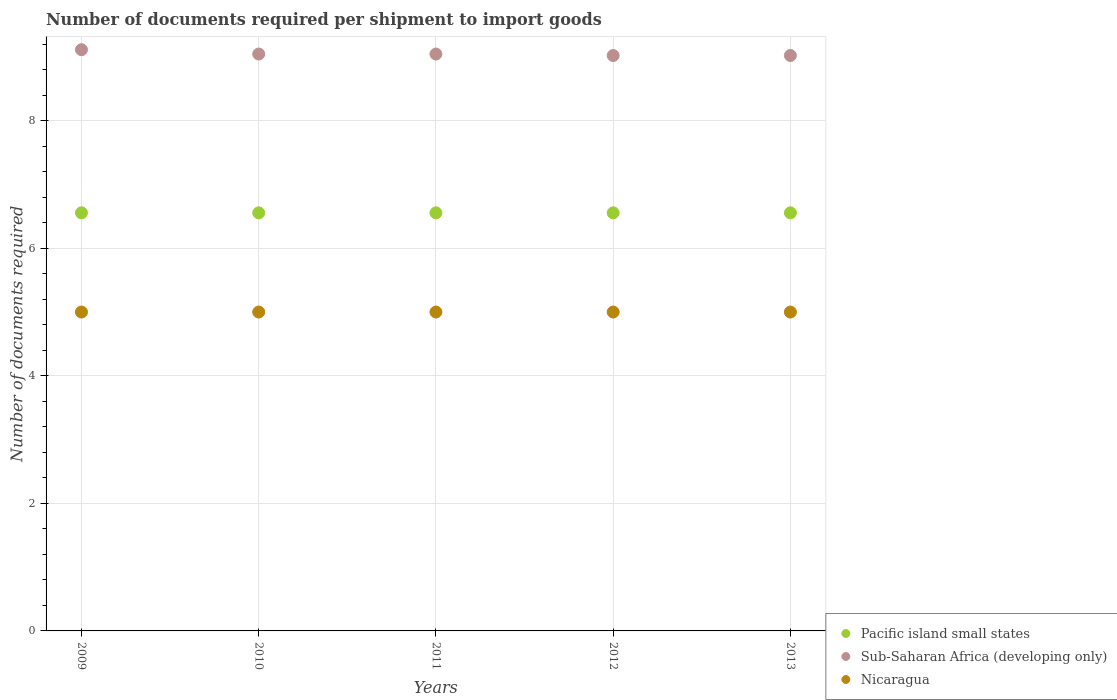What is the number of documents required per shipment to import goods in Sub-Saharan Africa (developing only) in 2013?
Offer a terse response. 9.02. Across all years, what is the maximum number of documents required per shipment to import goods in Nicaragua?
Keep it short and to the point. 5. Across all years, what is the minimum number of documents required per shipment to import goods in Sub-Saharan Africa (developing only)?
Offer a very short reply. 9.02. In which year was the number of documents required per shipment to import goods in Nicaragua minimum?
Your answer should be very brief. 2009. What is the total number of documents required per shipment to import goods in Pacific island small states in the graph?
Offer a very short reply. 32.78. What is the difference between the number of documents required per shipment to import goods in Pacific island small states in 2011 and the number of documents required per shipment to import goods in Nicaragua in 2012?
Provide a short and direct response. 1.56. What is the average number of documents required per shipment to import goods in Nicaragua per year?
Offer a terse response. 5. In the year 2013, what is the difference between the number of documents required per shipment to import goods in Sub-Saharan Africa (developing only) and number of documents required per shipment to import goods in Nicaragua?
Keep it short and to the point. 4.02. What is the ratio of the number of documents required per shipment to import goods in Nicaragua in 2009 to that in 2010?
Make the answer very short. 1. Is the number of documents required per shipment to import goods in Sub-Saharan Africa (developing only) in 2009 less than that in 2012?
Your answer should be very brief. No. What is the difference between the highest and the second highest number of documents required per shipment to import goods in Sub-Saharan Africa (developing only)?
Your answer should be compact. 0.07. In how many years, is the number of documents required per shipment to import goods in Pacific island small states greater than the average number of documents required per shipment to import goods in Pacific island small states taken over all years?
Your answer should be very brief. 0. What is the difference between two consecutive major ticks on the Y-axis?
Give a very brief answer. 2. Does the graph contain grids?
Provide a succinct answer. Yes. Where does the legend appear in the graph?
Provide a short and direct response. Bottom right. How many legend labels are there?
Make the answer very short. 3. How are the legend labels stacked?
Offer a terse response. Vertical. What is the title of the graph?
Offer a very short reply. Number of documents required per shipment to import goods. What is the label or title of the X-axis?
Your answer should be very brief. Years. What is the label or title of the Y-axis?
Give a very brief answer. Number of documents required. What is the Number of documents required of Pacific island small states in 2009?
Offer a terse response. 6.56. What is the Number of documents required of Sub-Saharan Africa (developing only) in 2009?
Keep it short and to the point. 9.11. What is the Number of documents required of Pacific island small states in 2010?
Provide a succinct answer. 6.56. What is the Number of documents required in Sub-Saharan Africa (developing only) in 2010?
Ensure brevity in your answer.  9.05. What is the Number of documents required of Nicaragua in 2010?
Make the answer very short. 5. What is the Number of documents required in Pacific island small states in 2011?
Ensure brevity in your answer.  6.56. What is the Number of documents required of Sub-Saharan Africa (developing only) in 2011?
Make the answer very short. 9.05. What is the Number of documents required in Nicaragua in 2011?
Your answer should be compact. 5. What is the Number of documents required in Pacific island small states in 2012?
Keep it short and to the point. 6.56. What is the Number of documents required of Sub-Saharan Africa (developing only) in 2012?
Give a very brief answer. 9.02. What is the Number of documents required of Pacific island small states in 2013?
Keep it short and to the point. 6.56. What is the Number of documents required of Sub-Saharan Africa (developing only) in 2013?
Give a very brief answer. 9.02. What is the Number of documents required of Nicaragua in 2013?
Your answer should be compact. 5. Across all years, what is the maximum Number of documents required of Pacific island small states?
Offer a very short reply. 6.56. Across all years, what is the maximum Number of documents required of Sub-Saharan Africa (developing only)?
Keep it short and to the point. 9.11. Across all years, what is the maximum Number of documents required in Nicaragua?
Your response must be concise. 5. Across all years, what is the minimum Number of documents required of Pacific island small states?
Make the answer very short. 6.56. Across all years, what is the minimum Number of documents required in Sub-Saharan Africa (developing only)?
Offer a very short reply. 9.02. What is the total Number of documents required in Pacific island small states in the graph?
Offer a terse response. 32.78. What is the total Number of documents required in Sub-Saharan Africa (developing only) in the graph?
Your answer should be compact. 45.25. What is the difference between the Number of documents required of Sub-Saharan Africa (developing only) in 2009 and that in 2010?
Keep it short and to the point. 0.07. What is the difference between the Number of documents required of Nicaragua in 2009 and that in 2010?
Your answer should be compact. 0. What is the difference between the Number of documents required of Sub-Saharan Africa (developing only) in 2009 and that in 2011?
Your answer should be compact. 0.07. What is the difference between the Number of documents required in Pacific island small states in 2009 and that in 2012?
Provide a succinct answer. 0. What is the difference between the Number of documents required of Sub-Saharan Africa (developing only) in 2009 and that in 2012?
Offer a very short reply. 0.09. What is the difference between the Number of documents required of Sub-Saharan Africa (developing only) in 2009 and that in 2013?
Your answer should be very brief. 0.09. What is the difference between the Number of documents required in Nicaragua in 2009 and that in 2013?
Your answer should be compact. 0. What is the difference between the Number of documents required in Pacific island small states in 2010 and that in 2011?
Make the answer very short. 0. What is the difference between the Number of documents required in Sub-Saharan Africa (developing only) in 2010 and that in 2011?
Make the answer very short. 0. What is the difference between the Number of documents required in Pacific island small states in 2010 and that in 2012?
Keep it short and to the point. 0. What is the difference between the Number of documents required in Sub-Saharan Africa (developing only) in 2010 and that in 2012?
Your response must be concise. 0.02. What is the difference between the Number of documents required of Nicaragua in 2010 and that in 2012?
Ensure brevity in your answer.  0. What is the difference between the Number of documents required of Sub-Saharan Africa (developing only) in 2010 and that in 2013?
Ensure brevity in your answer.  0.02. What is the difference between the Number of documents required in Sub-Saharan Africa (developing only) in 2011 and that in 2012?
Offer a terse response. 0.02. What is the difference between the Number of documents required in Pacific island small states in 2011 and that in 2013?
Offer a terse response. 0. What is the difference between the Number of documents required of Sub-Saharan Africa (developing only) in 2011 and that in 2013?
Make the answer very short. 0.02. What is the difference between the Number of documents required in Pacific island small states in 2009 and the Number of documents required in Sub-Saharan Africa (developing only) in 2010?
Your answer should be compact. -2.49. What is the difference between the Number of documents required of Pacific island small states in 2009 and the Number of documents required of Nicaragua in 2010?
Give a very brief answer. 1.56. What is the difference between the Number of documents required of Sub-Saharan Africa (developing only) in 2009 and the Number of documents required of Nicaragua in 2010?
Provide a succinct answer. 4.11. What is the difference between the Number of documents required of Pacific island small states in 2009 and the Number of documents required of Sub-Saharan Africa (developing only) in 2011?
Ensure brevity in your answer.  -2.49. What is the difference between the Number of documents required in Pacific island small states in 2009 and the Number of documents required in Nicaragua in 2011?
Provide a succinct answer. 1.56. What is the difference between the Number of documents required in Sub-Saharan Africa (developing only) in 2009 and the Number of documents required in Nicaragua in 2011?
Offer a very short reply. 4.11. What is the difference between the Number of documents required in Pacific island small states in 2009 and the Number of documents required in Sub-Saharan Africa (developing only) in 2012?
Make the answer very short. -2.47. What is the difference between the Number of documents required in Pacific island small states in 2009 and the Number of documents required in Nicaragua in 2012?
Provide a succinct answer. 1.56. What is the difference between the Number of documents required of Sub-Saharan Africa (developing only) in 2009 and the Number of documents required of Nicaragua in 2012?
Ensure brevity in your answer.  4.11. What is the difference between the Number of documents required in Pacific island small states in 2009 and the Number of documents required in Sub-Saharan Africa (developing only) in 2013?
Give a very brief answer. -2.47. What is the difference between the Number of documents required in Pacific island small states in 2009 and the Number of documents required in Nicaragua in 2013?
Your answer should be compact. 1.56. What is the difference between the Number of documents required in Sub-Saharan Africa (developing only) in 2009 and the Number of documents required in Nicaragua in 2013?
Give a very brief answer. 4.11. What is the difference between the Number of documents required of Pacific island small states in 2010 and the Number of documents required of Sub-Saharan Africa (developing only) in 2011?
Offer a terse response. -2.49. What is the difference between the Number of documents required of Pacific island small states in 2010 and the Number of documents required of Nicaragua in 2011?
Ensure brevity in your answer.  1.56. What is the difference between the Number of documents required in Sub-Saharan Africa (developing only) in 2010 and the Number of documents required in Nicaragua in 2011?
Provide a short and direct response. 4.05. What is the difference between the Number of documents required in Pacific island small states in 2010 and the Number of documents required in Sub-Saharan Africa (developing only) in 2012?
Make the answer very short. -2.47. What is the difference between the Number of documents required of Pacific island small states in 2010 and the Number of documents required of Nicaragua in 2012?
Your answer should be very brief. 1.56. What is the difference between the Number of documents required of Sub-Saharan Africa (developing only) in 2010 and the Number of documents required of Nicaragua in 2012?
Make the answer very short. 4.05. What is the difference between the Number of documents required in Pacific island small states in 2010 and the Number of documents required in Sub-Saharan Africa (developing only) in 2013?
Your answer should be very brief. -2.47. What is the difference between the Number of documents required in Pacific island small states in 2010 and the Number of documents required in Nicaragua in 2013?
Your answer should be compact. 1.56. What is the difference between the Number of documents required of Sub-Saharan Africa (developing only) in 2010 and the Number of documents required of Nicaragua in 2013?
Your answer should be very brief. 4.05. What is the difference between the Number of documents required of Pacific island small states in 2011 and the Number of documents required of Sub-Saharan Africa (developing only) in 2012?
Ensure brevity in your answer.  -2.47. What is the difference between the Number of documents required in Pacific island small states in 2011 and the Number of documents required in Nicaragua in 2012?
Give a very brief answer. 1.56. What is the difference between the Number of documents required in Sub-Saharan Africa (developing only) in 2011 and the Number of documents required in Nicaragua in 2012?
Provide a short and direct response. 4.05. What is the difference between the Number of documents required of Pacific island small states in 2011 and the Number of documents required of Sub-Saharan Africa (developing only) in 2013?
Your response must be concise. -2.47. What is the difference between the Number of documents required of Pacific island small states in 2011 and the Number of documents required of Nicaragua in 2013?
Your answer should be compact. 1.56. What is the difference between the Number of documents required of Sub-Saharan Africa (developing only) in 2011 and the Number of documents required of Nicaragua in 2013?
Ensure brevity in your answer.  4.05. What is the difference between the Number of documents required in Pacific island small states in 2012 and the Number of documents required in Sub-Saharan Africa (developing only) in 2013?
Your answer should be compact. -2.47. What is the difference between the Number of documents required of Pacific island small states in 2012 and the Number of documents required of Nicaragua in 2013?
Keep it short and to the point. 1.56. What is the difference between the Number of documents required in Sub-Saharan Africa (developing only) in 2012 and the Number of documents required in Nicaragua in 2013?
Keep it short and to the point. 4.02. What is the average Number of documents required in Pacific island small states per year?
Give a very brief answer. 6.56. What is the average Number of documents required in Sub-Saharan Africa (developing only) per year?
Keep it short and to the point. 9.05. What is the average Number of documents required of Nicaragua per year?
Provide a succinct answer. 5. In the year 2009, what is the difference between the Number of documents required in Pacific island small states and Number of documents required in Sub-Saharan Africa (developing only)?
Make the answer very short. -2.56. In the year 2009, what is the difference between the Number of documents required in Pacific island small states and Number of documents required in Nicaragua?
Provide a short and direct response. 1.56. In the year 2009, what is the difference between the Number of documents required in Sub-Saharan Africa (developing only) and Number of documents required in Nicaragua?
Keep it short and to the point. 4.11. In the year 2010, what is the difference between the Number of documents required of Pacific island small states and Number of documents required of Sub-Saharan Africa (developing only)?
Make the answer very short. -2.49. In the year 2010, what is the difference between the Number of documents required in Pacific island small states and Number of documents required in Nicaragua?
Give a very brief answer. 1.56. In the year 2010, what is the difference between the Number of documents required of Sub-Saharan Africa (developing only) and Number of documents required of Nicaragua?
Give a very brief answer. 4.05. In the year 2011, what is the difference between the Number of documents required of Pacific island small states and Number of documents required of Sub-Saharan Africa (developing only)?
Your answer should be very brief. -2.49. In the year 2011, what is the difference between the Number of documents required of Pacific island small states and Number of documents required of Nicaragua?
Provide a short and direct response. 1.56. In the year 2011, what is the difference between the Number of documents required of Sub-Saharan Africa (developing only) and Number of documents required of Nicaragua?
Keep it short and to the point. 4.05. In the year 2012, what is the difference between the Number of documents required in Pacific island small states and Number of documents required in Sub-Saharan Africa (developing only)?
Your answer should be very brief. -2.47. In the year 2012, what is the difference between the Number of documents required in Pacific island small states and Number of documents required in Nicaragua?
Provide a succinct answer. 1.56. In the year 2012, what is the difference between the Number of documents required of Sub-Saharan Africa (developing only) and Number of documents required of Nicaragua?
Give a very brief answer. 4.02. In the year 2013, what is the difference between the Number of documents required in Pacific island small states and Number of documents required in Sub-Saharan Africa (developing only)?
Give a very brief answer. -2.47. In the year 2013, what is the difference between the Number of documents required of Pacific island small states and Number of documents required of Nicaragua?
Ensure brevity in your answer.  1.56. In the year 2013, what is the difference between the Number of documents required in Sub-Saharan Africa (developing only) and Number of documents required in Nicaragua?
Keep it short and to the point. 4.02. What is the ratio of the Number of documents required of Pacific island small states in 2009 to that in 2010?
Your response must be concise. 1. What is the ratio of the Number of documents required in Sub-Saharan Africa (developing only) in 2009 to that in 2010?
Your response must be concise. 1.01. What is the ratio of the Number of documents required of Nicaragua in 2009 to that in 2010?
Your response must be concise. 1. What is the ratio of the Number of documents required in Pacific island small states in 2009 to that in 2011?
Your answer should be compact. 1. What is the ratio of the Number of documents required of Sub-Saharan Africa (developing only) in 2009 to that in 2011?
Your answer should be very brief. 1.01. What is the ratio of the Number of documents required in Pacific island small states in 2009 to that in 2013?
Ensure brevity in your answer.  1. What is the ratio of the Number of documents required in Pacific island small states in 2010 to that in 2011?
Provide a succinct answer. 1. What is the ratio of the Number of documents required of Nicaragua in 2010 to that in 2011?
Provide a succinct answer. 1. What is the ratio of the Number of documents required of Pacific island small states in 2010 to that in 2012?
Offer a terse response. 1. What is the ratio of the Number of documents required in Nicaragua in 2010 to that in 2012?
Offer a terse response. 1. What is the ratio of the Number of documents required in Sub-Saharan Africa (developing only) in 2010 to that in 2013?
Make the answer very short. 1. What is the ratio of the Number of documents required of Nicaragua in 2010 to that in 2013?
Your answer should be compact. 1. What is the ratio of the Number of documents required in Nicaragua in 2011 to that in 2012?
Ensure brevity in your answer.  1. What is the ratio of the Number of documents required of Sub-Saharan Africa (developing only) in 2011 to that in 2013?
Your answer should be compact. 1. What is the ratio of the Number of documents required in Nicaragua in 2011 to that in 2013?
Give a very brief answer. 1. What is the ratio of the Number of documents required in Sub-Saharan Africa (developing only) in 2012 to that in 2013?
Make the answer very short. 1. What is the ratio of the Number of documents required in Nicaragua in 2012 to that in 2013?
Offer a terse response. 1. What is the difference between the highest and the second highest Number of documents required in Sub-Saharan Africa (developing only)?
Keep it short and to the point. 0.07. What is the difference between the highest and the lowest Number of documents required in Sub-Saharan Africa (developing only)?
Offer a terse response. 0.09. What is the difference between the highest and the lowest Number of documents required of Nicaragua?
Your answer should be very brief. 0. 